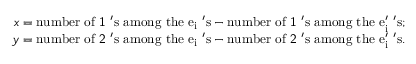Convert formula to latex. <formula><loc_0><loc_0><loc_500><loc_500>\begin{array} { r } { x = n u m b e r o f 1 ^ { \prime } s a m o n g t h e e _ { i } ^ { \prime } s - n u m b e r o f 1 ^ { \prime } s a m o n g t h e e _ { i } ^ { \prime } ^ { \prime } s ; } \\ { y = n u m b e r o f 2 ^ { \prime } s a m o n g t h e e _ { i } ^ { \prime } s - n u m b e r o f 2 ^ { \prime } s a m o n g t h e e _ { i } ^ { \prime } ^ { \prime } s . } \end{array}</formula> 